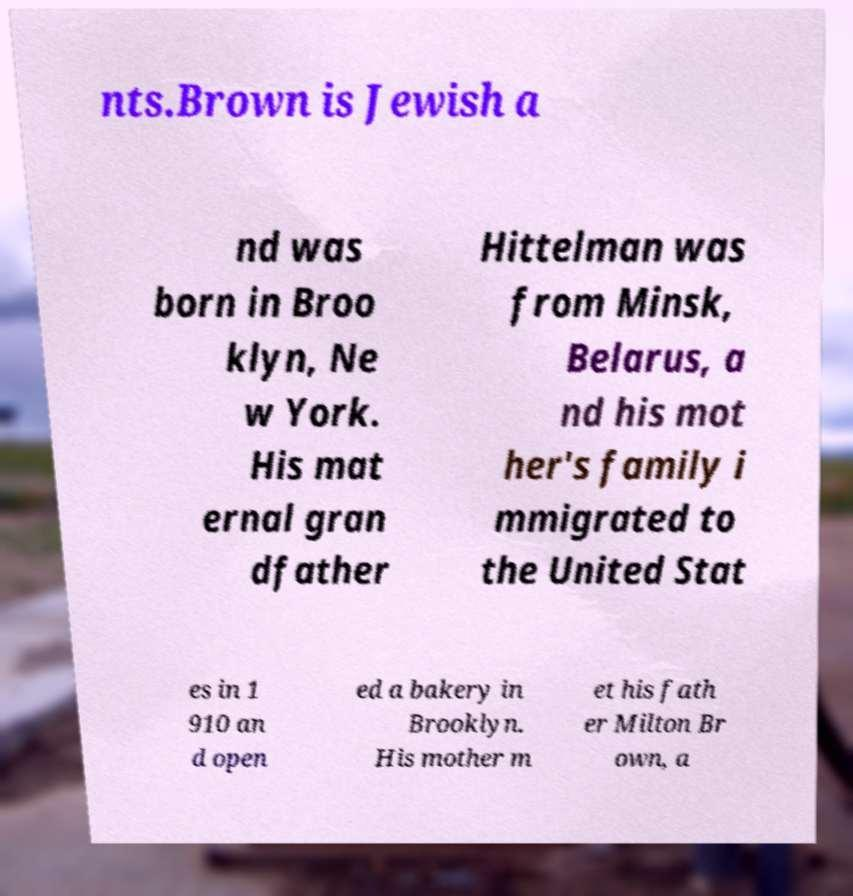Can you read and provide the text displayed in the image?This photo seems to have some interesting text. Can you extract and type it out for me? nts.Brown is Jewish a nd was born in Broo klyn, Ne w York. His mat ernal gran dfather Hittelman was from Minsk, Belarus, a nd his mot her's family i mmigrated to the United Stat es in 1 910 an d open ed a bakery in Brooklyn. His mother m et his fath er Milton Br own, a 